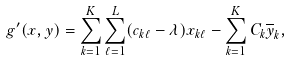<formula> <loc_0><loc_0><loc_500><loc_500>g ^ { \prime } ( x , y ) = \sum _ { k = 1 } ^ { K } \sum _ { \ell = 1 } ^ { L } ( c _ { k \ell } - \lambda ) x _ { k \ell } - \sum _ { k = 1 } ^ { K } C _ { k } \overline { y } _ { k } ,</formula> 